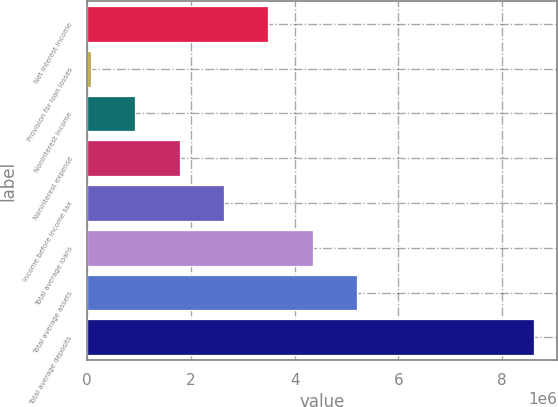Convert chart to OTSL. <chart><loc_0><loc_0><loc_500><loc_500><bar_chart><fcel>Net interest income<fcel>Provision for loan losses<fcel>Noninterest income<fcel>Noninterest expense<fcel>Income before income tax<fcel>Total average loans<fcel>Total average assets<fcel>Total average deposits<nl><fcel>3.49324e+06<fcel>76011<fcel>930318<fcel>1.78462e+06<fcel>2.63893e+06<fcel>4.34754e+06<fcel>5.20185e+06<fcel>8.61908e+06<nl></chart> 